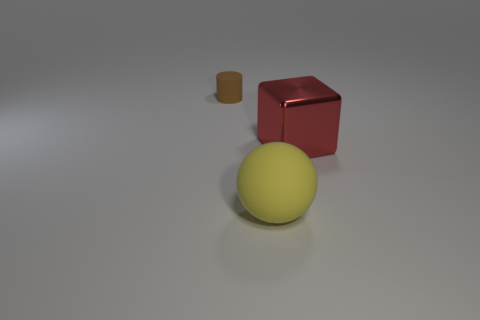What is the shape of the brown thing?
Ensure brevity in your answer.  Cylinder. Are there fewer big shiny blocks to the left of the large yellow thing than shiny objects?
Provide a succinct answer. Yes. Are there any big yellow objects that have the same shape as the large red metallic thing?
Offer a terse response. No. What is the shape of the yellow matte object that is the same size as the block?
Ensure brevity in your answer.  Sphere. What number of objects are blue metallic cylinders or things?
Your answer should be very brief. 3. Is there a brown cylinder?
Your answer should be very brief. Yes. Is the number of red blocks less than the number of big cyan metal balls?
Offer a terse response. No. Are there any cyan blocks that have the same size as the brown thing?
Provide a short and direct response. No. How many blocks are rubber things or large brown matte things?
Provide a short and direct response. 0. The tiny cylinder has what color?
Provide a short and direct response. Brown. 